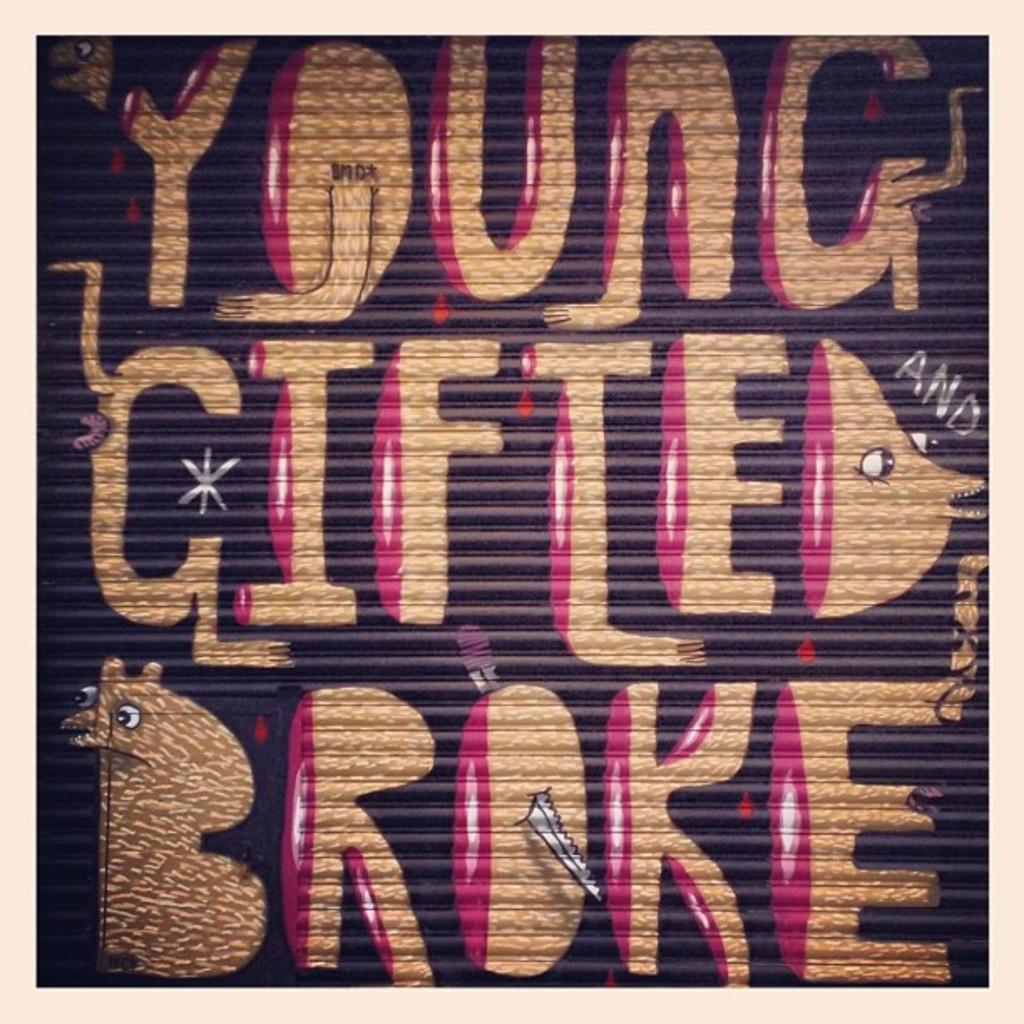How would you summarize this image in a sentence or two? In this image we can see come colorful text. 